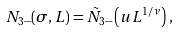Convert formula to latex. <formula><loc_0><loc_0><loc_500><loc_500>N _ { 3 - } ( \sigma , L ) = \tilde { N } _ { 3 - } \left ( u L ^ { 1 / \nu } \right ) \, ,</formula> 